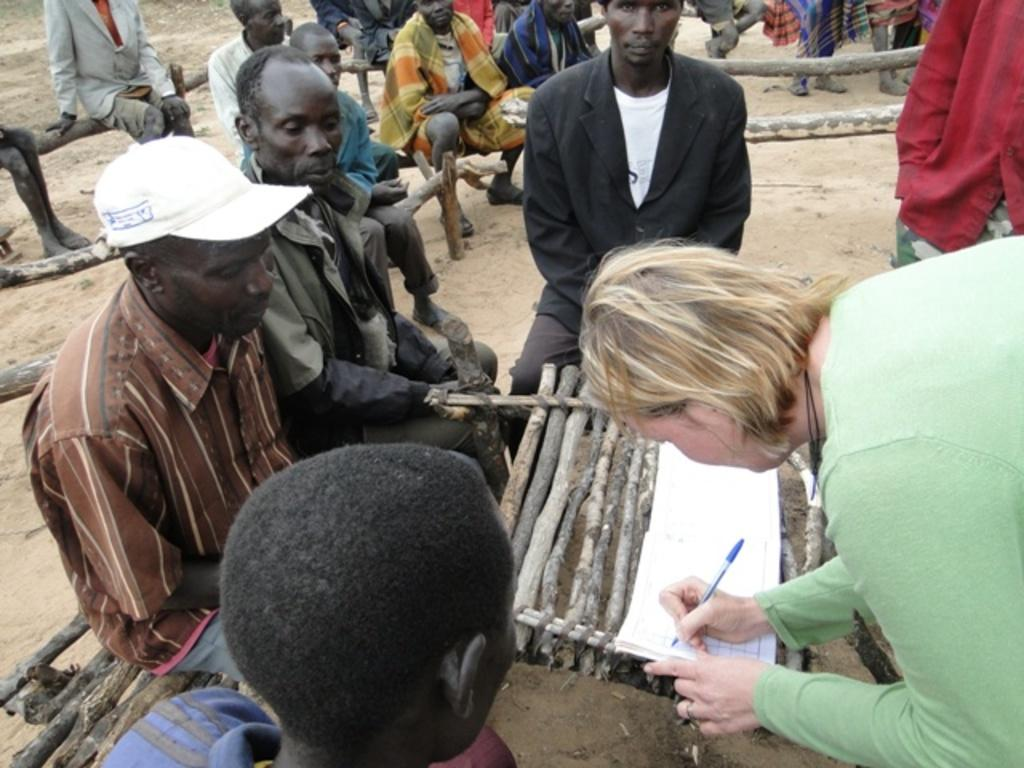What are the people in the image doing? The people in the image are sitting. What is the woman holding in the image? The woman is holding a book and a pen. What type of waves can be seen in the image? There are no waves present in the image. What color is the woman's eye in the image? The color of the woman's eye cannot be determined from the image, as it is not visible. 